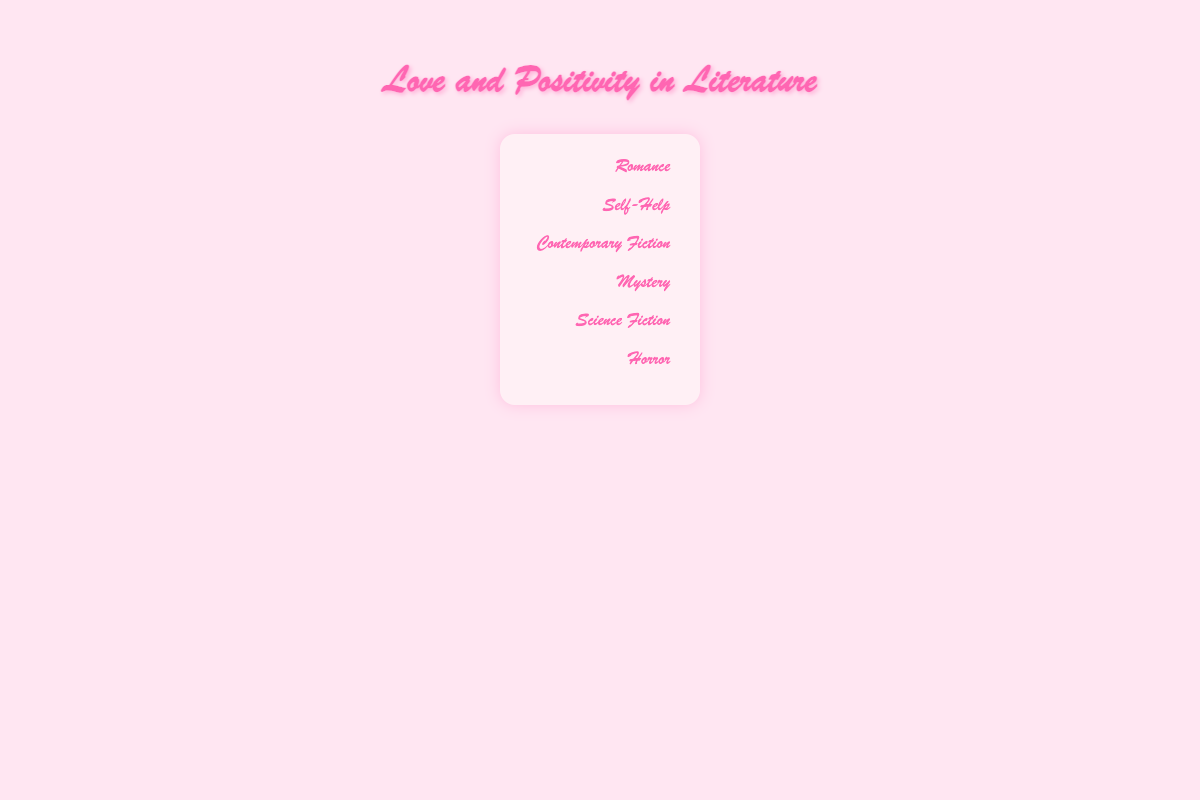What's the title of the chart? The title is displayed at the top of the chart. The colorful, cursive font draws attention to it.
Answer: Love and Positivity in Literature Which genre has the most positive affirmations? By counting the icons representing positive affirmations for each genre, Romance has the most.
Answer: Romance Which genre visually appears to have the fewest uplifting themes? The genre with the fewest icons representing uplifting themes is Horror.
Answer: Horror How many positive affirmations and uplifting themes are seen in Self-Help books? Count the icons representing positive affirmations (78) and uplifting themes (80) for Self-Help.
Answer: Positive Affirmations: 78, Uplifting Themes: 80 Do Romance novels have more positive affirmations or uplifting themes? Compare the icons for positive affirmations (85) and uplifting themes (92) in the Romance genre.
Answer: Uplifting themes Which genres have more uplifting themes than positive affirmations? For each genre, compare the number of uplifting themes to positive affirmations. Self-Help and Horror have more uplifting themes than positive affirmations.
Answer: Self-Help, Horror What is the difference in uplifting themes between Contemporary Fiction and Romance? Subtract the number of uplifting themes in Contemporary Fiction (52) from that in Romance (92).
Answer: 40 Relative to Mystery, how many more positive affirmations does Contemporary Fiction have? Subtract the positive affirmations in Mystery (20) from those in Contemporary Fiction (45).
Answer: 25 When comparing Science Fiction to Self-Help, how many more positive affirmations does Self-Help have? Subtract the positive affirmations in Science Fiction (30) from those in Self-Help (78).
Answer: 48 What's the total number of uplifting themes across all genres? Sum the number of uplifting themes for all genres: 92 (Romance) + 80 (Self-Help) + 52 (Contemporary Fiction) + 25 (Mystery) + 35 (Science Fiction) + 8 (Horror).
Answer: 292 